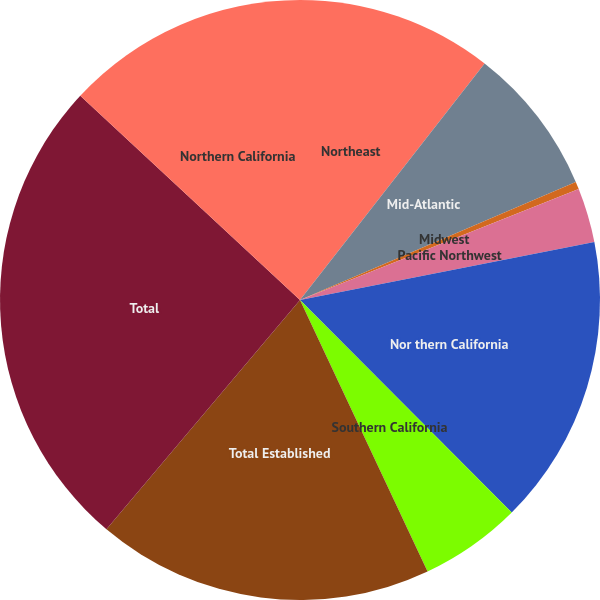Convert chart to OTSL. <chart><loc_0><loc_0><loc_500><loc_500><pie_chart><fcel>Northeast<fcel>Mid-Atlantic<fcel>Midwest<fcel>Pacific Northwest<fcel>Nor thern California<fcel>Southern California<fcel>Total Established<fcel>Total<fcel>Northern California<nl><fcel>10.55%<fcel>8.01%<fcel>0.41%<fcel>2.94%<fcel>15.62%<fcel>5.48%<fcel>18.15%<fcel>25.76%<fcel>13.08%<nl></chart> 